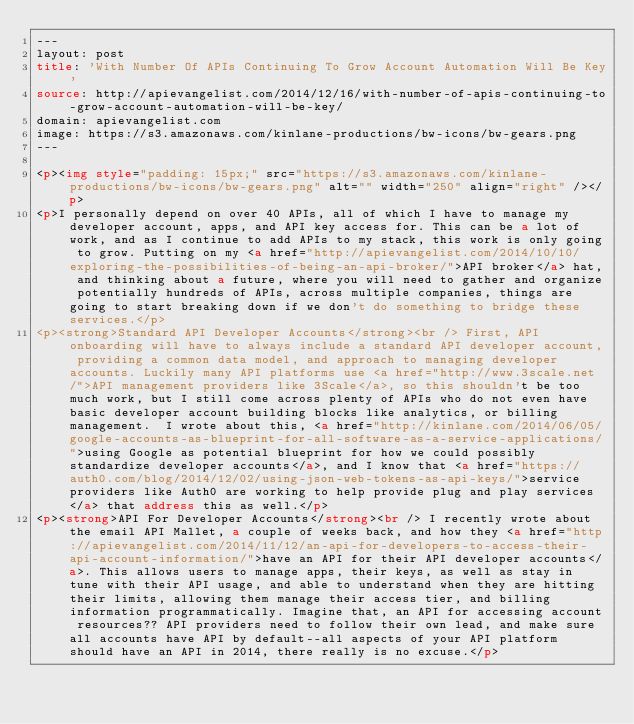<code> <loc_0><loc_0><loc_500><loc_500><_HTML_>---
layout: post
title: 'With Number Of APIs Continuing To Grow Account Automation Will Be Key'
source: http://apievangelist.com/2014/12/16/with-number-of-apis-continuing-to-grow-account-automation-will-be-key/
domain: apievangelist.com
image: https://s3.amazonaws.com/kinlane-productions/bw-icons/bw-gears.png
---

<p><img style="padding: 15px;" src="https://s3.amazonaws.com/kinlane-productions/bw-icons/bw-gears.png" alt="" width="250" align="right" /></p>
<p>I personally depend on over 40 APIs, all of which I have to manage my developer account, apps, and API key access for. This can be a lot of work, and as I continue to add APIs to my stack, this work is only going to grow. Putting on my <a href="http://apievangelist.com/2014/10/10/exploring-the-possibilities-of-being-an-api-broker/">API broker</a> hat, and thinking about a future, where you will need to gather and organize potentially hundreds of APIs, across multiple companies, things are going to start breaking down if we don't do something to bridge these services.</p>
<p><strong>Standard API Developer Accounts</strong><br /> First, API onboarding will have to always include a standard API developer account, providing a common data model, and approach to managing developer accounts. Luckily many API platforms use <a href="http://www.3scale.net/">API management providers like 3Scale</a>, so this shouldn't be too much work, but I still come across plenty of APIs who do not even have basic developer account building blocks like analytics, or billing management.  I wrote about this, <a href="http://kinlane.com/2014/06/05/google-accounts-as-blueprint-for-all-software-as-a-service-applications/">using Google as potential blueprint for how we could possibly standardize developer accounts</a>, and I know that <a href="https://auth0.com/blog/2014/12/02/using-json-web-tokens-as-api-keys/">service providers like Auth0 are working to help provide plug and play services</a> that address this as well.</p>
<p><strong>API For Developer Accounts</strong><br /> I recently wrote about the email API Mallet, a couple of weeks back, and how they <a href="http://apievangelist.com/2014/11/12/an-api-for-developers-to-access-their-api-account-information/">have an API for their API developer accounts</a>. This allows users to manage apps, their keys, as well as stay in tune with their API usage, and able to understand when they are hitting their limits, allowing them manage their access tier, and billing information programmatically. Imagine that, an API for accessing account resources?? API providers need to follow their own lead, and make sure all accounts have API by default--all aspects of your API platform should have an API in 2014, there really is no excuse.</p></code> 